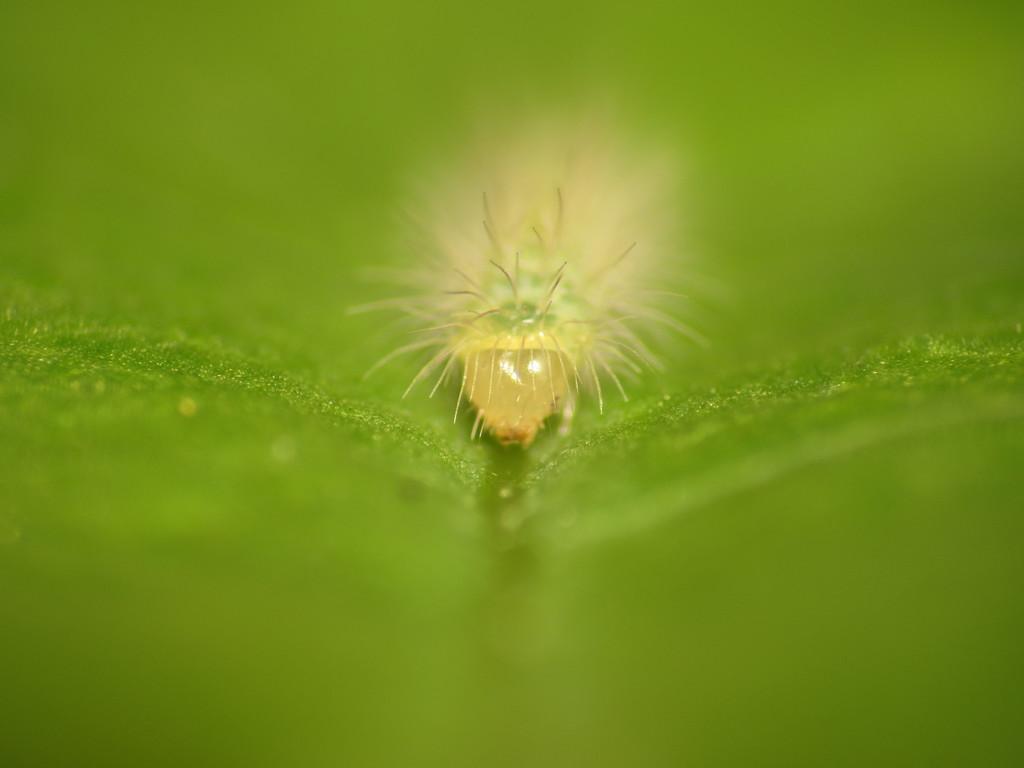Describe this image in one or two sentences. In the center of the picture there is an insect like thing on a green color object. 